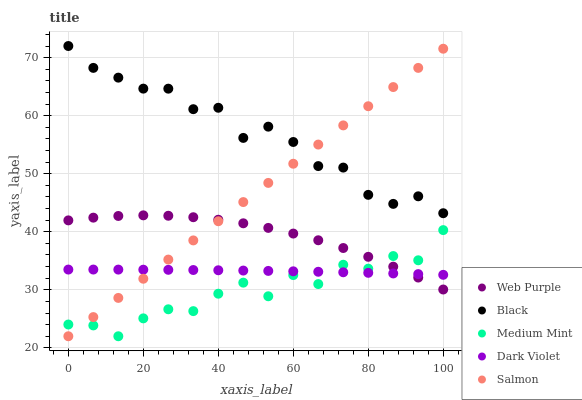Does Medium Mint have the minimum area under the curve?
Answer yes or no. Yes. Does Black have the maximum area under the curve?
Answer yes or no. Yes. Does Salmon have the minimum area under the curve?
Answer yes or no. No. Does Salmon have the maximum area under the curve?
Answer yes or no. No. Is Salmon the smoothest?
Answer yes or no. Yes. Is Medium Mint the roughest?
Answer yes or no. Yes. Is Web Purple the smoothest?
Answer yes or no. No. Is Web Purple the roughest?
Answer yes or no. No. Does Medium Mint have the lowest value?
Answer yes or no. Yes. Does Web Purple have the lowest value?
Answer yes or no. No. Does Black have the highest value?
Answer yes or no. Yes. Does Salmon have the highest value?
Answer yes or no. No. Is Medium Mint less than Black?
Answer yes or no. Yes. Is Black greater than Dark Violet?
Answer yes or no. Yes. Does Dark Violet intersect Medium Mint?
Answer yes or no. Yes. Is Dark Violet less than Medium Mint?
Answer yes or no. No. Is Dark Violet greater than Medium Mint?
Answer yes or no. No. Does Medium Mint intersect Black?
Answer yes or no. No. 